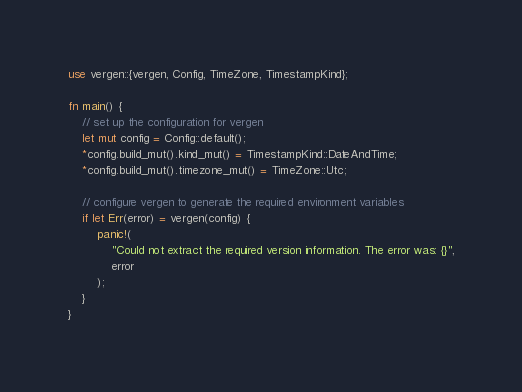<code> <loc_0><loc_0><loc_500><loc_500><_Rust_>use vergen::{vergen, Config, TimeZone, TimestampKind};

fn main() {
    // set up the configuration for vergen
    let mut config = Config::default();
    *config.build_mut().kind_mut() = TimestampKind::DateAndTime;
    *config.build_mut().timezone_mut() = TimeZone::Utc;

    // configure vergen to generate the required environment variables
    if let Err(error) = vergen(config) {
        panic!(
            "Could not extract the required version information. The error was: {}",
            error
        );
    }
}
</code> 